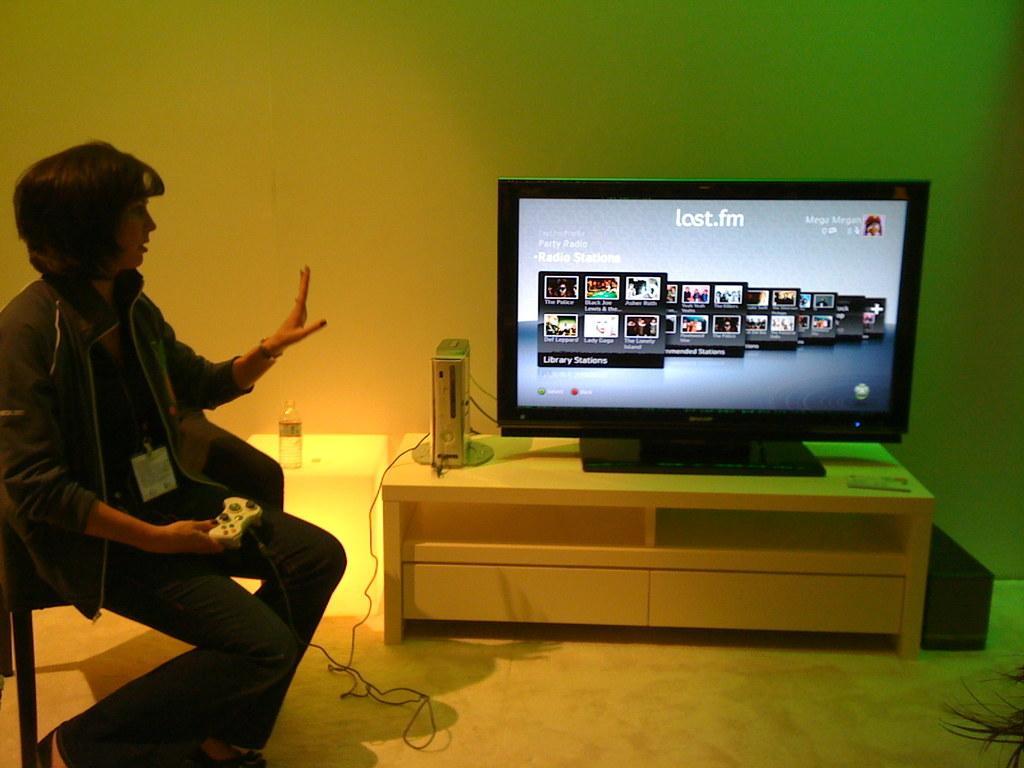Can you describe this image briefly? In this picture, there is a woman sitting on the chair and holding a remote. She is wearing a black jacket and black trousers. Towards the right, there is a television on the table. Beside the television, there is a device with a wire. On the screen, there are some pictures and text. Behind the television, there is a wall. 